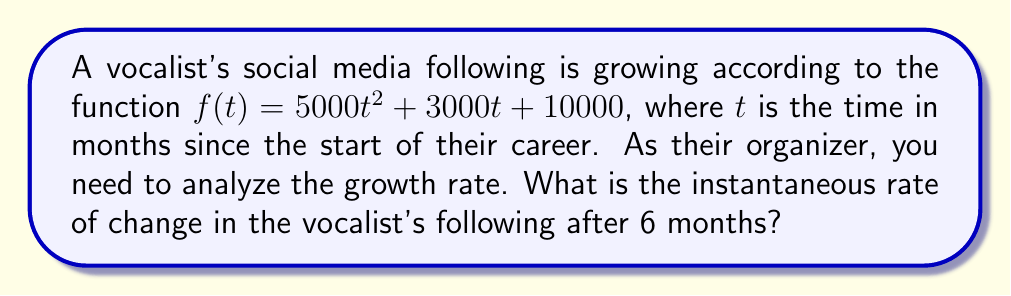Provide a solution to this math problem. To find the instantaneous rate of change, we need to calculate the derivative of the function and evaluate it at $t = 6$.

1. Given function: $f(t) = 5000t^2 + 3000t + 10000$

2. Calculate the derivative:
   $f'(t) = \frac{d}{dt}(5000t^2 + 3000t + 10000)$
   $f'(t) = 10000t + 3000$

3. Evaluate the derivative at $t = 6$:
   $f'(6) = 10000(6) + 3000$
   $f'(6) = 60000 + 3000$
   $f'(6) = 63000$

The instantaneous rate of change after 6 months is 63,000 followers per month.
Answer: 63,000 followers/month 